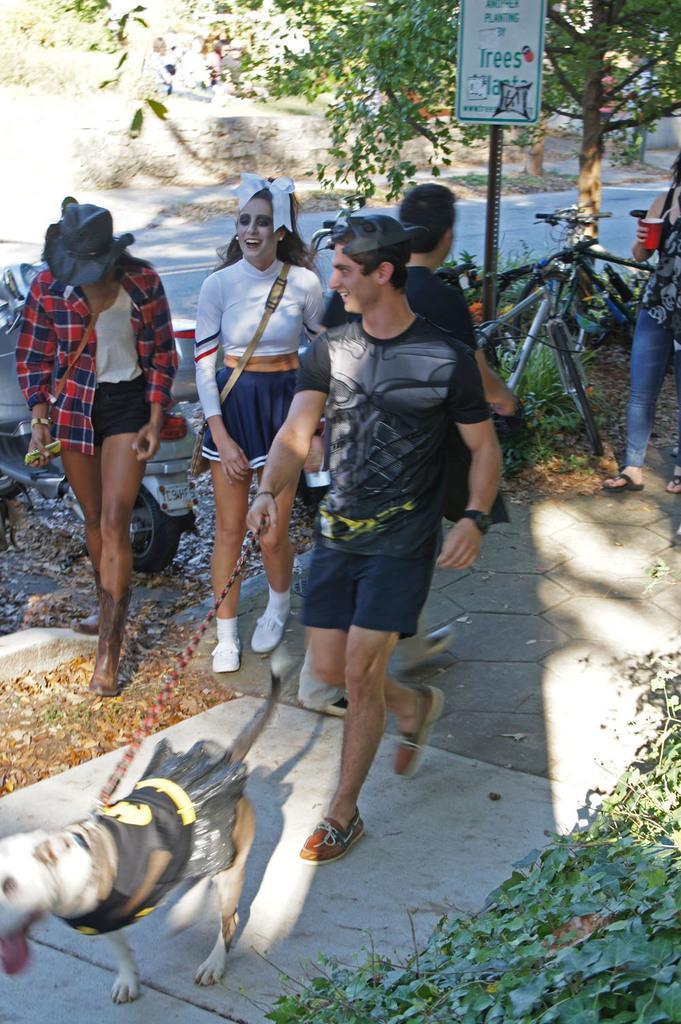Can you describe this image briefly? In this image there are so many people walking on the road in which one of them is holding dog behind them there is bicycle, trees and hill. 